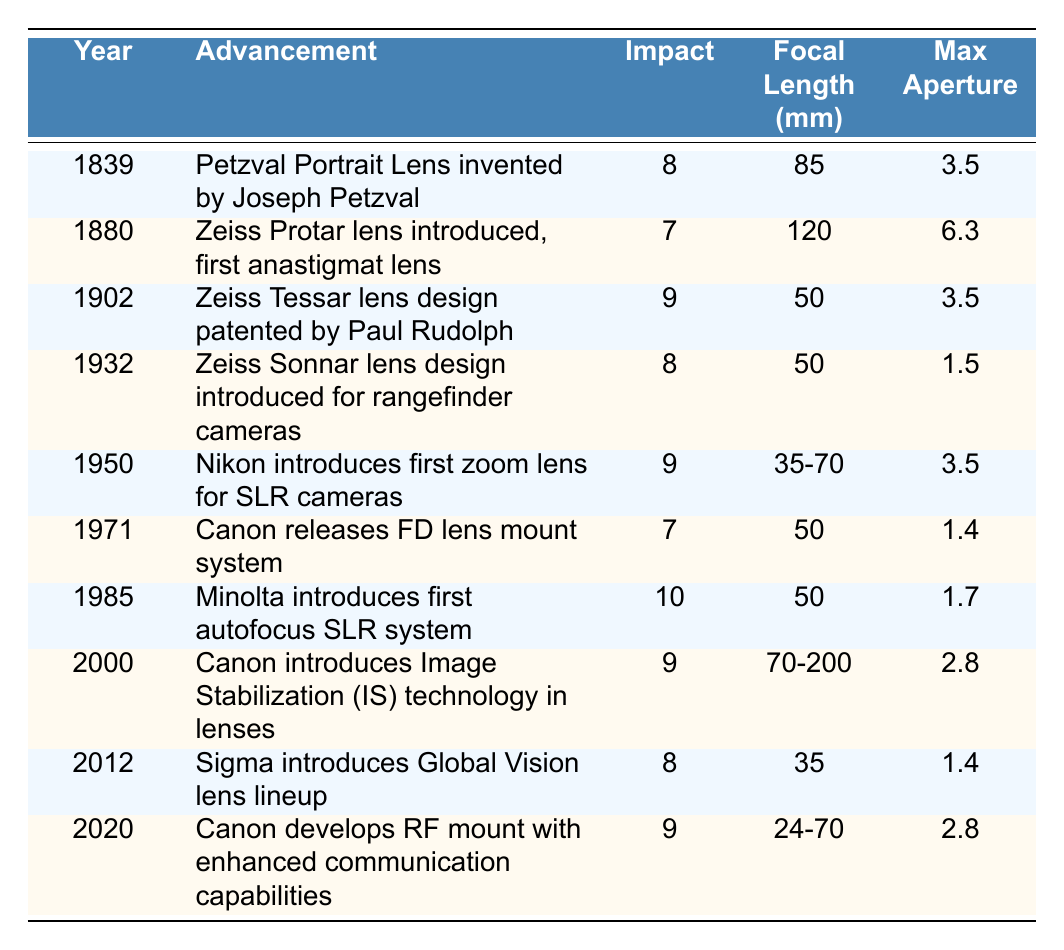What was the impact rating of the Zeiss Tessar lens design? According to the table, the impact rating for the Zeiss Tessar lens design patented by Paul Rudolph in 1902 was 9.
Answer: 9 What is the maximum aperture of the lens introduced in 1971? In the table, it is noted that the maximum aperture of the lens released by Canon in 1971 is 1.4.
Answer: 1.4 Which advancement had the highest impact rating? The table shows that the Minolta autofocus SLR system introduced in 1985 had the highest impact rating of 10.
Answer: 10 What advancements occurred in the 20th century? The advancements listed for the 20th century (from 1902 to 2000) are: Zeiss Tessar lens design, Zeiss Sonnar lens design, Nikon's first zoom lens, Canon's FD mount, Minolta autofocus SLR, and Canon's Image Stabilization.
Answer: Six Is the Focal Length of the Petzval Portrait Lens greater than 100mm? The table indicates that the focal length of the Petzval Portrait Lens is 85mm, which is less than 100mm.
Answer: No What is the average maximum aperture of the lenses introduced between 1950 and 2020? The maximum apertures between these years are 3.5 (1950), 1.4 (1971), 1.7 (1985), 2.8 (2000), 1.4 (2012), and 2.8 (2020). Summing them gives 13.2, and dividing by 6 gives an average of 2.2.
Answer: 2.2 Which lens had an impact rating of 9 and was introduced after 2000? The table shows that the Canon RF mount, introduced in 2020, had an impact rating of 9.
Answer: Canon RF mount What is the focal length range of the first zoom lens produced by Nikon? The focal length stated in the table for Nikon's first zoom lens introduced in 1950 is 35-70mm.
Answer: 35-70mm What was the most recent advancement listed in the table? The table shows that the most recent advancement is Canon developing the RF mount in 2020.
Answer: Canon RF mount How many advancements were introduced with an impact rating of 8? By checking the table, three advancements (Petzval lens, Zeiss Sonnar design, Sigma Global Vision) have an impact rating of 8 listed.
Answer: Three 